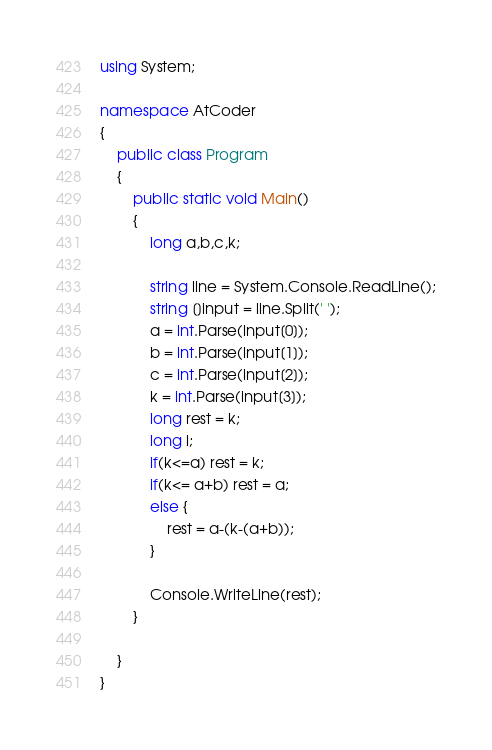Convert code to text. <code><loc_0><loc_0><loc_500><loc_500><_C#_>using System;

namespace AtCoder
{
    public class Program
    {
        public static void Main()
        {
            long a,b,c,k;

            string line = System.Console.ReadLine();
            string []input = line.Split(' ');
            a = int.Parse(input[0]);
            b = int.Parse(input[1]);
            c = int.Parse(input[2]);
            k = int.Parse(input[3]);
            long rest = k;
            long i;
            if(k<=a) rest = k;
            if(k<= a+b) rest = a;
            else {
                rest = a-(k-(a+b));
            }

            Console.WriteLine(rest);
        }

    }
}</code> 